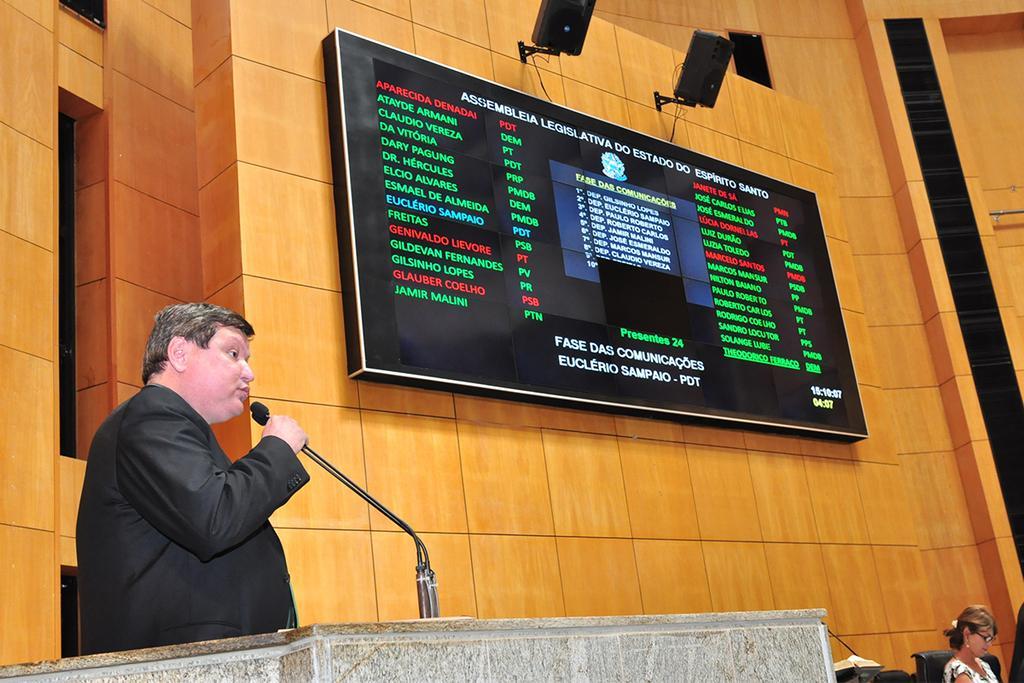Could you give a brief overview of what you see in this image? This picture shows a display screen to the wall and couple of speakers fixed to the wall and we see a man standing at a podium and speaking with the help of a microphone and we see a woman seated on the chair. 